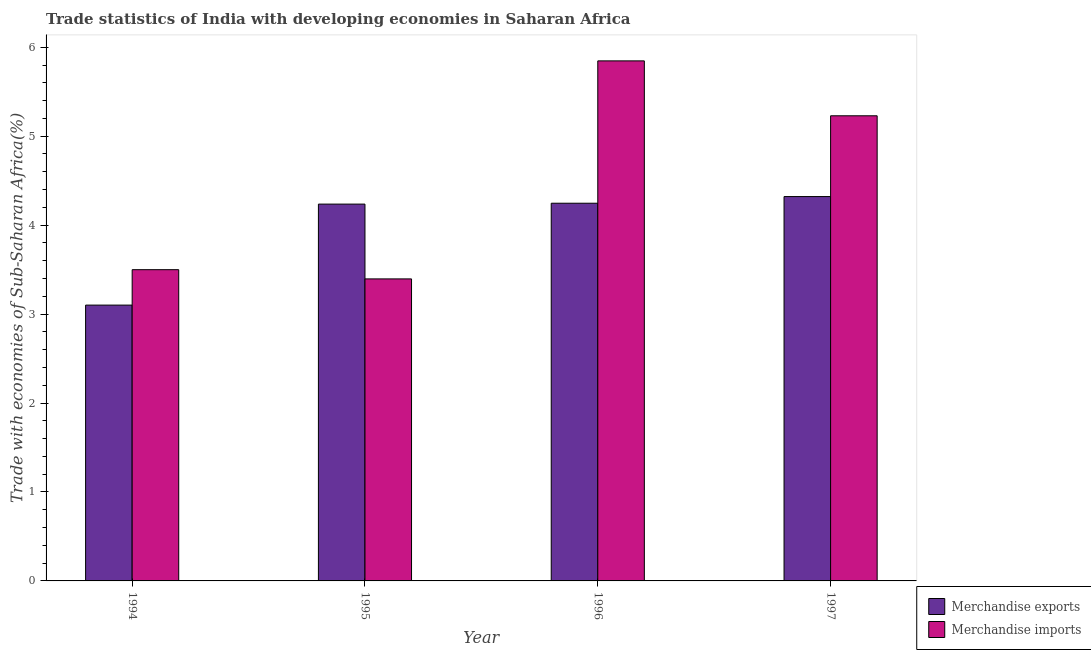How many groups of bars are there?
Provide a short and direct response. 4. How many bars are there on the 4th tick from the right?
Ensure brevity in your answer.  2. What is the label of the 3rd group of bars from the left?
Give a very brief answer. 1996. In how many cases, is the number of bars for a given year not equal to the number of legend labels?
Your answer should be very brief. 0. What is the merchandise exports in 1996?
Ensure brevity in your answer.  4.25. Across all years, what is the maximum merchandise exports?
Offer a very short reply. 4.32. Across all years, what is the minimum merchandise exports?
Give a very brief answer. 3.1. In which year was the merchandise exports maximum?
Provide a short and direct response. 1997. In which year was the merchandise exports minimum?
Provide a succinct answer. 1994. What is the total merchandise exports in the graph?
Ensure brevity in your answer.  15.9. What is the difference between the merchandise exports in 1995 and that in 1996?
Make the answer very short. -0.01. What is the difference between the merchandise exports in 1996 and the merchandise imports in 1994?
Offer a very short reply. 1.15. What is the average merchandise imports per year?
Your answer should be very brief. 4.49. In the year 1995, what is the difference between the merchandise imports and merchandise exports?
Provide a succinct answer. 0. What is the ratio of the merchandise exports in 1994 to that in 1997?
Ensure brevity in your answer.  0.72. Is the difference between the merchandise imports in 1996 and 1997 greater than the difference between the merchandise exports in 1996 and 1997?
Provide a succinct answer. No. What is the difference between the highest and the second highest merchandise exports?
Offer a terse response. 0.07. What is the difference between the highest and the lowest merchandise imports?
Make the answer very short. 2.45. In how many years, is the merchandise exports greater than the average merchandise exports taken over all years?
Make the answer very short. 3. What does the 2nd bar from the left in 1994 represents?
Give a very brief answer. Merchandise imports. What is the difference between two consecutive major ticks on the Y-axis?
Your answer should be very brief. 1. Where does the legend appear in the graph?
Provide a short and direct response. Bottom right. How many legend labels are there?
Your response must be concise. 2. What is the title of the graph?
Offer a very short reply. Trade statistics of India with developing economies in Saharan Africa. What is the label or title of the Y-axis?
Make the answer very short. Trade with economies of Sub-Saharan Africa(%). What is the Trade with economies of Sub-Saharan Africa(%) of Merchandise exports in 1994?
Provide a short and direct response. 3.1. What is the Trade with economies of Sub-Saharan Africa(%) in Merchandise imports in 1994?
Offer a terse response. 3.5. What is the Trade with economies of Sub-Saharan Africa(%) in Merchandise exports in 1995?
Provide a succinct answer. 4.24. What is the Trade with economies of Sub-Saharan Africa(%) of Merchandise imports in 1995?
Keep it short and to the point. 3.4. What is the Trade with economies of Sub-Saharan Africa(%) of Merchandise exports in 1996?
Ensure brevity in your answer.  4.25. What is the Trade with economies of Sub-Saharan Africa(%) of Merchandise imports in 1996?
Your answer should be compact. 5.85. What is the Trade with economies of Sub-Saharan Africa(%) of Merchandise exports in 1997?
Offer a very short reply. 4.32. What is the Trade with economies of Sub-Saharan Africa(%) of Merchandise imports in 1997?
Make the answer very short. 5.23. Across all years, what is the maximum Trade with economies of Sub-Saharan Africa(%) of Merchandise exports?
Ensure brevity in your answer.  4.32. Across all years, what is the maximum Trade with economies of Sub-Saharan Africa(%) of Merchandise imports?
Provide a succinct answer. 5.85. Across all years, what is the minimum Trade with economies of Sub-Saharan Africa(%) of Merchandise exports?
Keep it short and to the point. 3.1. Across all years, what is the minimum Trade with economies of Sub-Saharan Africa(%) of Merchandise imports?
Give a very brief answer. 3.4. What is the total Trade with economies of Sub-Saharan Africa(%) of Merchandise exports in the graph?
Ensure brevity in your answer.  15.9. What is the total Trade with economies of Sub-Saharan Africa(%) of Merchandise imports in the graph?
Ensure brevity in your answer.  17.97. What is the difference between the Trade with economies of Sub-Saharan Africa(%) in Merchandise exports in 1994 and that in 1995?
Provide a short and direct response. -1.14. What is the difference between the Trade with economies of Sub-Saharan Africa(%) of Merchandise imports in 1994 and that in 1995?
Your answer should be compact. 0.1. What is the difference between the Trade with economies of Sub-Saharan Africa(%) of Merchandise exports in 1994 and that in 1996?
Make the answer very short. -1.15. What is the difference between the Trade with economies of Sub-Saharan Africa(%) of Merchandise imports in 1994 and that in 1996?
Your response must be concise. -2.35. What is the difference between the Trade with economies of Sub-Saharan Africa(%) of Merchandise exports in 1994 and that in 1997?
Give a very brief answer. -1.22. What is the difference between the Trade with economies of Sub-Saharan Africa(%) in Merchandise imports in 1994 and that in 1997?
Provide a short and direct response. -1.73. What is the difference between the Trade with economies of Sub-Saharan Africa(%) in Merchandise exports in 1995 and that in 1996?
Give a very brief answer. -0.01. What is the difference between the Trade with economies of Sub-Saharan Africa(%) of Merchandise imports in 1995 and that in 1996?
Provide a short and direct response. -2.45. What is the difference between the Trade with economies of Sub-Saharan Africa(%) of Merchandise exports in 1995 and that in 1997?
Offer a very short reply. -0.08. What is the difference between the Trade with economies of Sub-Saharan Africa(%) of Merchandise imports in 1995 and that in 1997?
Offer a very short reply. -1.83. What is the difference between the Trade with economies of Sub-Saharan Africa(%) of Merchandise exports in 1996 and that in 1997?
Provide a succinct answer. -0.07. What is the difference between the Trade with economies of Sub-Saharan Africa(%) in Merchandise imports in 1996 and that in 1997?
Keep it short and to the point. 0.62. What is the difference between the Trade with economies of Sub-Saharan Africa(%) in Merchandise exports in 1994 and the Trade with economies of Sub-Saharan Africa(%) in Merchandise imports in 1995?
Offer a very short reply. -0.29. What is the difference between the Trade with economies of Sub-Saharan Africa(%) of Merchandise exports in 1994 and the Trade with economies of Sub-Saharan Africa(%) of Merchandise imports in 1996?
Ensure brevity in your answer.  -2.75. What is the difference between the Trade with economies of Sub-Saharan Africa(%) of Merchandise exports in 1994 and the Trade with economies of Sub-Saharan Africa(%) of Merchandise imports in 1997?
Provide a succinct answer. -2.13. What is the difference between the Trade with economies of Sub-Saharan Africa(%) of Merchandise exports in 1995 and the Trade with economies of Sub-Saharan Africa(%) of Merchandise imports in 1996?
Keep it short and to the point. -1.61. What is the difference between the Trade with economies of Sub-Saharan Africa(%) of Merchandise exports in 1995 and the Trade with economies of Sub-Saharan Africa(%) of Merchandise imports in 1997?
Provide a short and direct response. -0.99. What is the difference between the Trade with economies of Sub-Saharan Africa(%) in Merchandise exports in 1996 and the Trade with economies of Sub-Saharan Africa(%) in Merchandise imports in 1997?
Offer a terse response. -0.98. What is the average Trade with economies of Sub-Saharan Africa(%) of Merchandise exports per year?
Give a very brief answer. 3.98. What is the average Trade with economies of Sub-Saharan Africa(%) of Merchandise imports per year?
Your answer should be very brief. 4.49. In the year 1994, what is the difference between the Trade with economies of Sub-Saharan Africa(%) of Merchandise exports and Trade with economies of Sub-Saharan Africa(%) of Merchandise imports?
Give a very brief answer. -0.4. In the year 1995, what is the difference between the Trade with economies of Sub-Saharan Africa(%) of Merchandise exports and Trade with economies of Sub-Saharan Africa(%) of Merchandise imports?
Offer a very short reply. 0.84. In the year 1996, what is the difference between the Trade with economies of Sub-Saharan Africa(%) of Merchandise exports and Trade with economies of Sub-Saharan Africa(%) of Merchandise imports?
Provide a short and direct response. -1.6. In the year 1997, what is the difference between the Trade with economies of Sub-Saharan Africa(%) of Merchandise exports and Trade with economies of Sub-Saharan Africa(%) of Merchandise imports?
Keep it short and to the point. -0.91. What is the ratio of the Trade with economies of Sub-Saharan Africa(%) of Merchandise exports in 1994 to that in 1995?
Provide a succinct answer. 0.73. What is the ratio of the Trade with economies of Sub-Saharan Africa(%) of Merchandise imports in 1994 to that in 1995?
Your answer should be very brief. 1.03. What is the ratio of the Trade with economies of Sub-Saharan Africa(%) in Merchandise exports in 1994 to that in 1996?
Give a very brief answer. 0.73. What is the ratio of the Trade with economies of Sub-Saharan Africa(%) in Merchandise imports in 1994 to that in 1996?
Offer a very short reply. 0.6. What is the ratio of the Trade with economies of Sub-Saharan Africa(%) in Merchandise exports in 1994 to that in 1997?
Make the answer very short. 0.72. What is the ratio of the Trade with economies of Sub-Saharan Africa(%) of Merchandise imports in 1994 to that in 1997?
Make the answer very short. 0.67. What is the ratio of the Trade with economies of Sub-Saharan Africa(%) of Merchandise exports in 1995 to that in 1996?
Give a very brief answer. 1. What is the ratio of the Trade with economies of Sub-Saharan Africa(%) in Merchandise imports in 1995 to that in 1996?
Provide a short and direct response. 0.58. What is the ratio of the Trade with economies of Sub-Saharan Africa(%) of Merchandise exports in 1995 to that in 1997?
Give a very brief answer. 0.98. What is the ratio of the Trade with economies of Sub-Saharan Africa(%) of Merchandise imports in 1995 to that in 1997?
Offer a very short reply. 0.65. What is the ratio of the Trade with economies of Sub-Saharan Africa(%) of Merchandise exports in 1996 to that in 1997?
Make the answer very short. 0.98. What is the ratio of the Trade with economies of Sub-Saharan Africa(%) of Merchandise imports in 1996 to that in 1997?
Keep it short and to the point. 1.12. What is the difference between the highest and the second highest Trade with economies of Sub-Saharan Africa(%) of Merchandise exports?
Offer a very short reply. 0.07. What is the difference between the highest and the second highest Trade with economies of Sub-Saharan Africa(%) in Merchandise imports?
Keep it short and to the point. 0.62. What is the difference between the highest and the lowest Trade with economies of Sub-Saharan Africa(%) in Merchandise exports?
Provide a short and direct response. 1.22. What is the difference between the highest and the lowest Trade with economies of Sub-Saharan Africa(%) of Merchandise imports?
Ensure brevity in your answer.  2.45. 